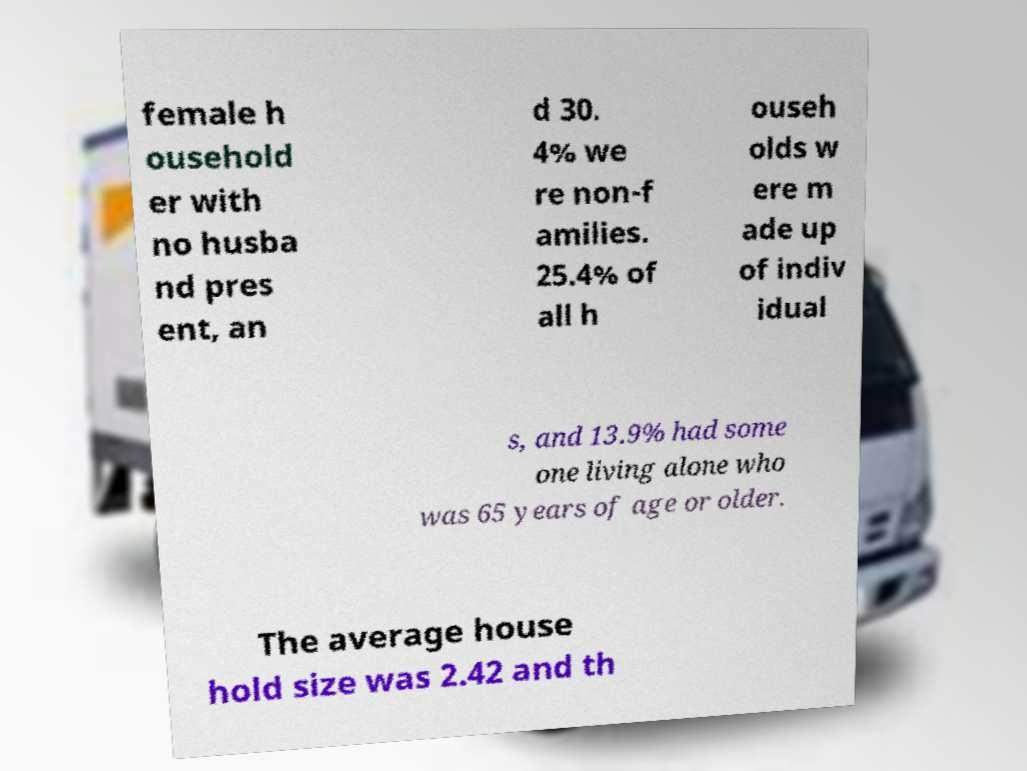I need the written content from this picture converted into text. Can you do that? female h ousehold er with no husba nd pres ent, an d 30. 4% we re non-f amilies. 25.4% of all h ouseh olds w ere m ade up of indiv idual s, and 13.9% had some one living alone who was 65 years of age or older. The average house hold size was 2.42 and th 